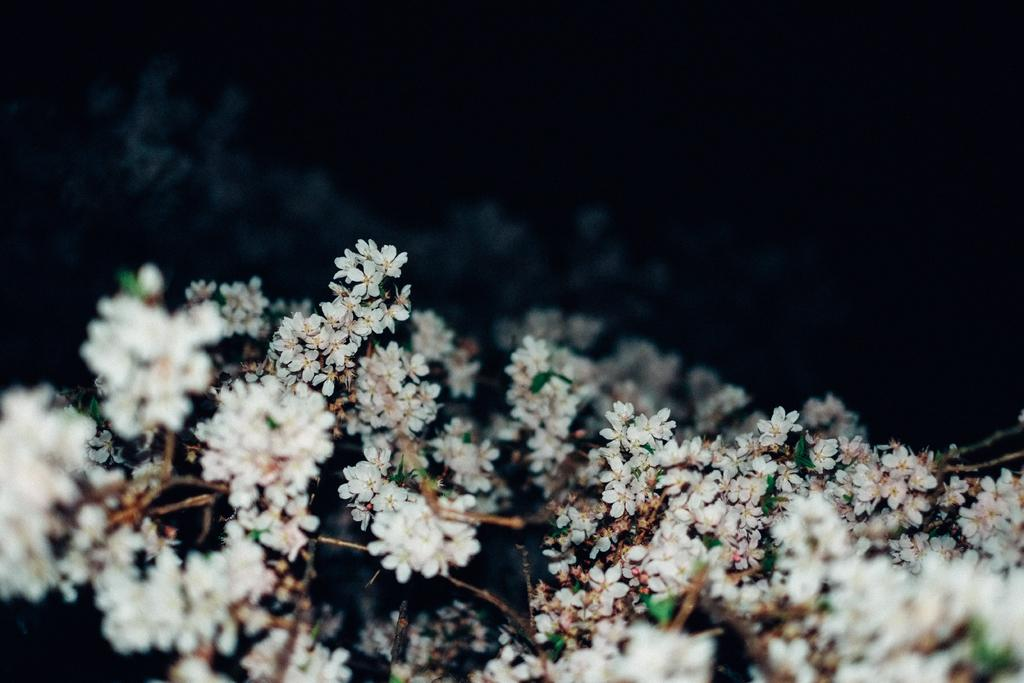What type of flowers can be seen in the image? There are white flowers in the image. What color is the background of the image? The background of the image is black. What type of furniture is depicted in the image? There is no furniture present in the image; it features white flowers against a black background. What historical event is being commemorated in the image? There is no historical event being commemorated in the image; it simply shows white flowers against a black background. 